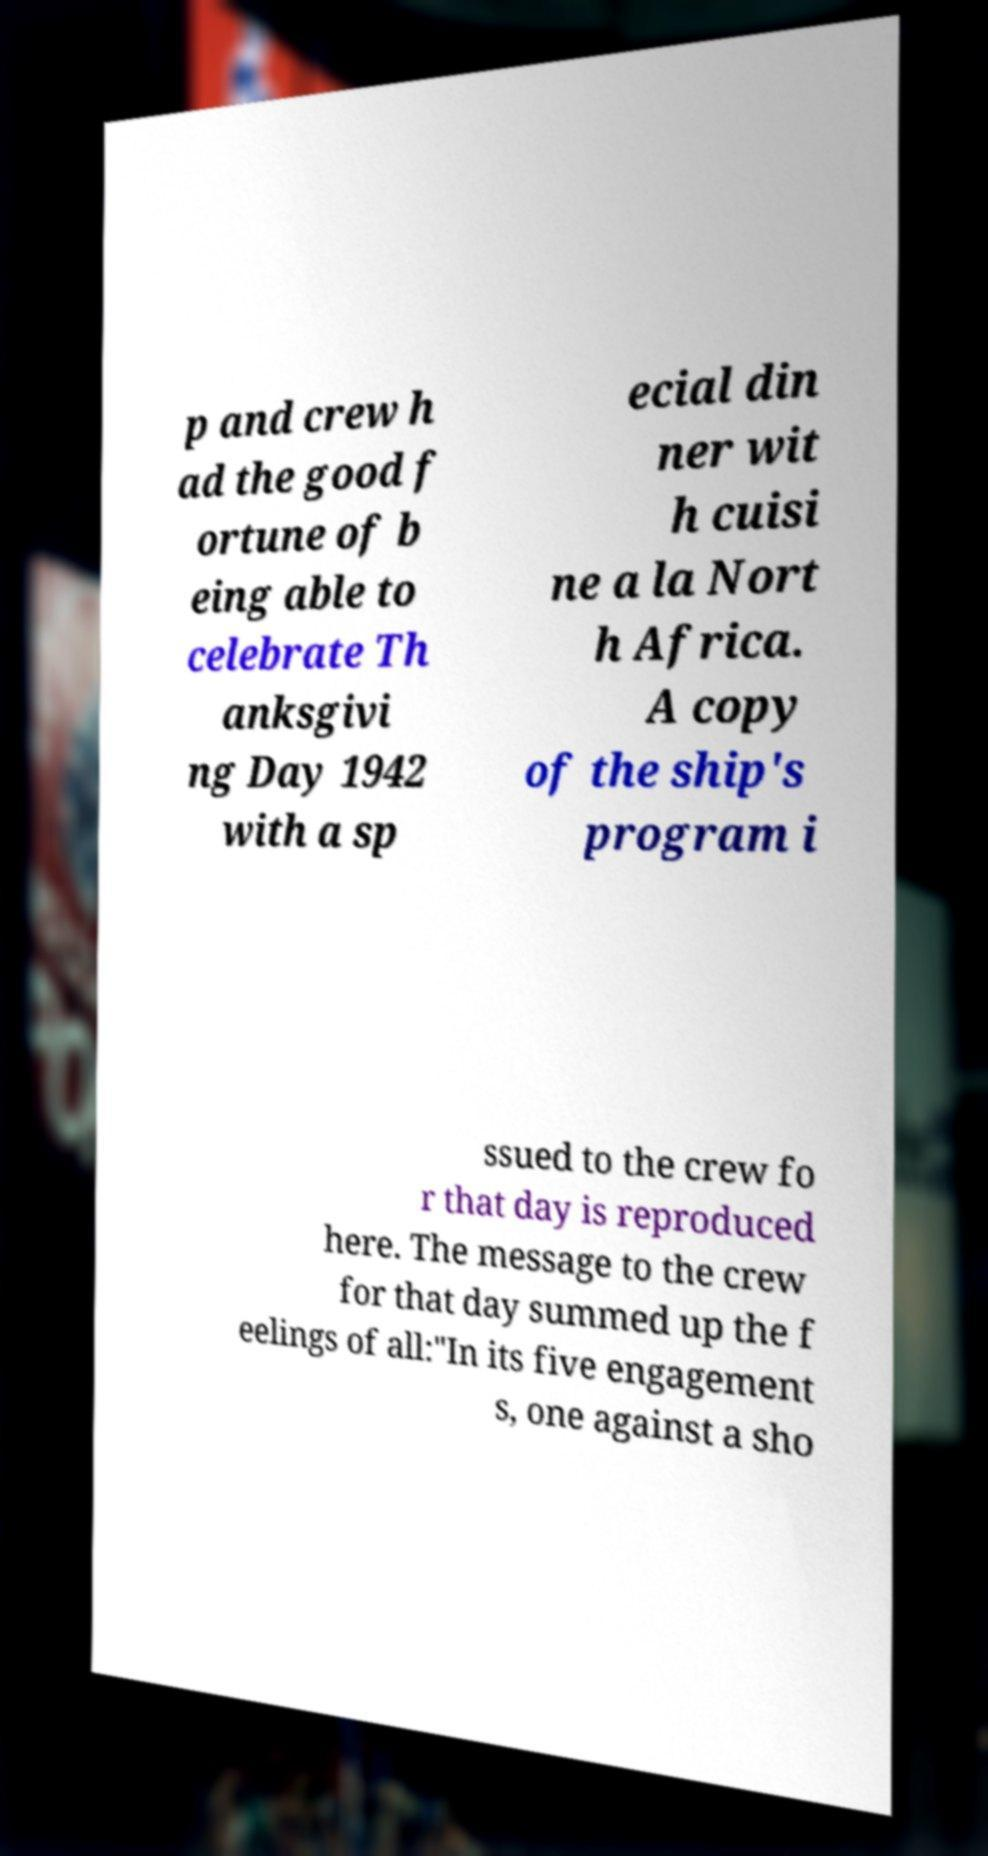For documentation purposes, I need the text within this image transcribed. Could you provide that? p and crew h ad the good f ortune of b eing able to celebrate Th anksgivi ng Day 1942 with a sp ecial din ner wit h cuisi ne a la Nort h Africa. A copy of the ship's program i ssued to the crew fo r that day is reproduced here. The message to the crew for that day summed up the f eelings of all:"In its five engagement s, one against a sho 